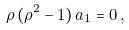<formula> <loc_0><loc_0><loc_500><loc_500>\rho \, ( \rho ^ { 2 } - 1 ) \, a _ { 1 } = 0 \, ,</formula> 